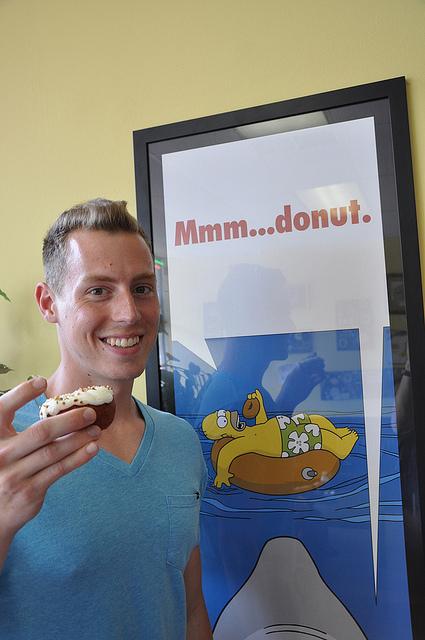What is the man eating?
Concise answer only. Donut. What is the person holding in his right hand?
Be succinct. Donut. What is this person eating?
Give a very brief answer. Donut. Is this a large donut?
Keep it brief. No. What series is the cartoon character from?
Keep it brief. Simpsons. Is the man well groomed?
Keep it brief. Yes. What is the man's name?
Short answer required. John. What are the men holding in their hands?
Quick response, please. Donut. How many eyes are there?
Be succinct. 4. What kind of frosting is on the doughnut?
Give a very brief answer. White. Is this a modern ad?
Keep it brief. Yes. Who is quoted in the image?
Quick response, please. Homer simpson. What day does the sign say it is?
Be succinct. None. Is this photograph film or digital?
Be succinct. Digital. Is this man happy?
Concise answer only. Yes. 